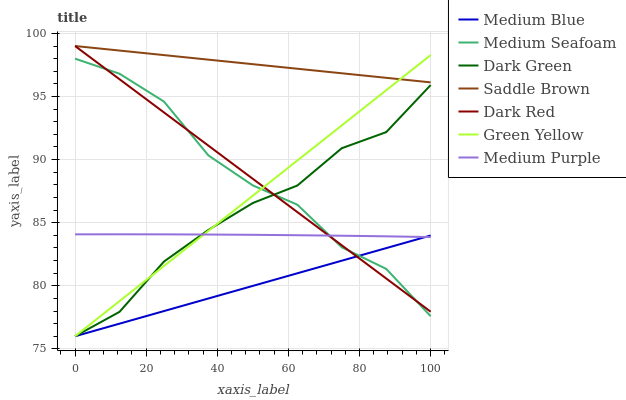Does Medium Blue have the minimum area under the curve?
Answer yes or no. Yes. Does Saddle Brown have the maximum area under the curve?
Answer yes or no. Yes. Does Medium Seafoam have the minimum area under the curve?
Answer yes or no. No. Does Medium Seafoam have the maximum area under the curve?
Answer yes or no. No. Is Green Yellow the smoothest?
Answer yes or no. Yes. Is Medium Seafoam the roughest?
Answer yes or no. Yes. Is Medium Blue the smoothest?
Answer yes or no. No. Is Medium Blue the roughest?
Answer yes or no. No. Does Medium Blue have the lowest value?
Answer yes or no. Yes. Does Medium Seafoam have the lowest value?
Answer yes or no. No. Does Saddle Brown have the highest value?
Answer yes or no. Yes. Does Medium Seafoam have the highest value?
Answer yes or no. No. Is Medium Seafoam less than Saddle Brown?
Answer yes or no. Yes. Is Saddle Brown greater than Medium Seafoam?
Answer yes or no. Yes. Does Medium Purple intersect Medium Blue?
Answer yes or no. Yes. Is Medium Purple less than Medium Blue?
Answer yes or no. No. Is Medium Purple greater than Medium Blue?
Answer yes or no. No. Does Medium Seafoam intersect Saddle Brown?
Answer yes or no. No. 